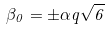<formula> <loc_0><loc_0><loc_500><loc_500>\beta _ { 0 } = \pm \alpha q \sqrt { 6 }</formula> 